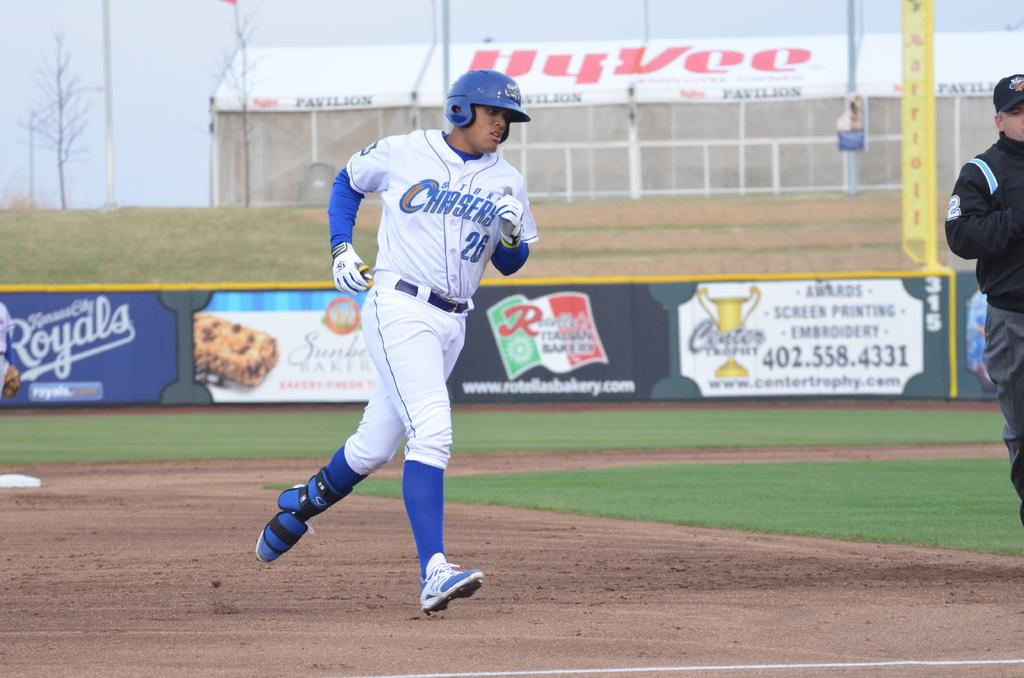Provide a one-sentence caption for the provided image. A baseball player in a Chasers uniform rounds the bases. 